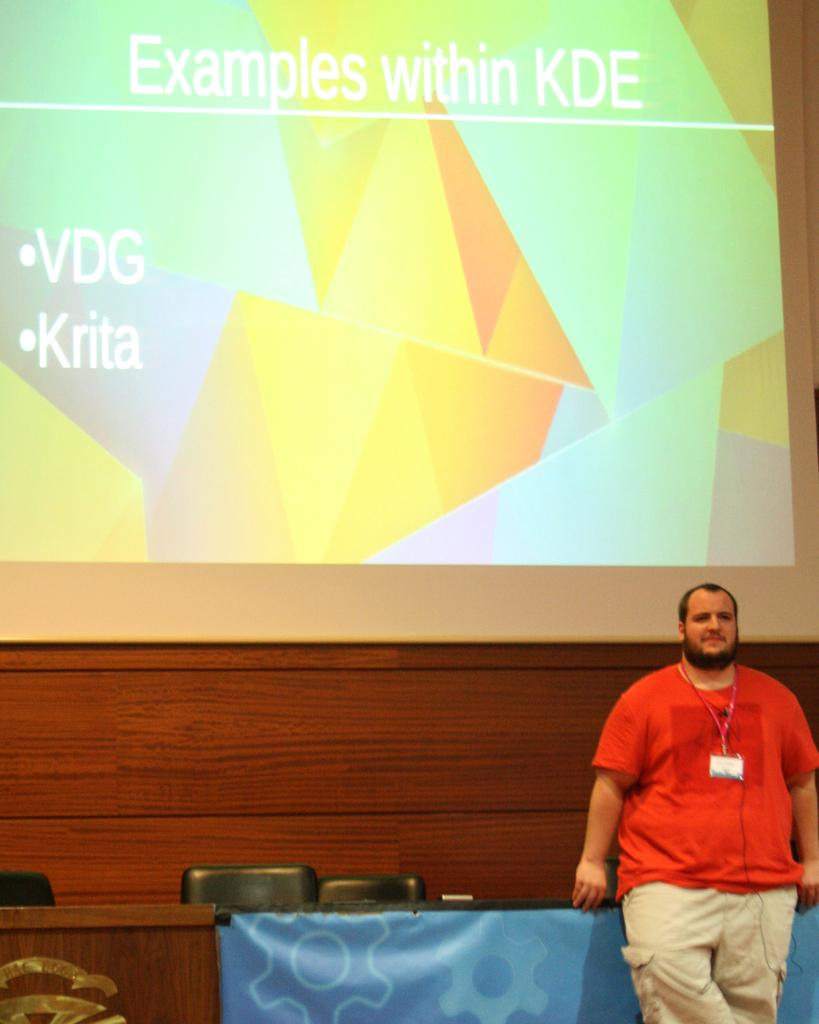What is the main subject of the image? There is a man standing in the image. What objects are present in the image besides the man? There is a table and chairs in the image. What can be seen on the table in the image? There is a screen visible on the table in the image. What type of hammer is the man using in the image? There is no hammer present in the image; the man is simply standing. What grade is the man teaching in the image? There is no indication of teaching or a specific grade in the image; it only shows a man standing. 